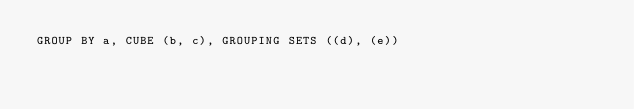<code> <loc_0><loc_0><loc_500><loc_500><_SQL_>GROUP BY a, CUBE (b, c), GROUPING SETS ((d), (e))
</code> 